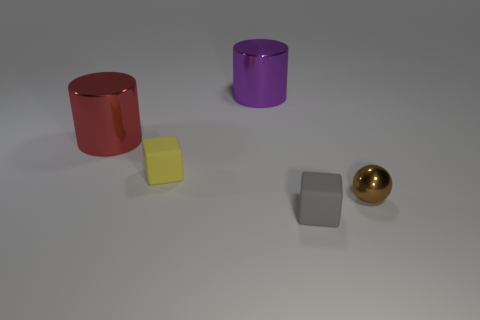What is the size of the brown object that is the same material as the red cylinder?
Keep it short and to the point. Small. Is the number of small yellow objects greater than the number of brown shiny blocks?
Give a very brief answer. Yes. What is the color of the metallic thing that is in front of the large red object?
Make the answer very short. Brown. There is a object that is on the left side of the ball and on the right side of the big purple cylinder; what size is it?
Make the answer very short. Small. How many yellow rubber things have the same size as the gray matte block?
Offer a terse response. 1. What material is the red thing that is the same shape as the purple metal object?
Your answer should be very brief. Metal. Does the red thing have the same shape as the yellow thing?
Ensure brevity in your answer.  No. How many red metal things are right of the small ball?
Provide a succinct answer. 0. There is a shiny object to the left of the big thing right of the tiny yellow rubber thing; what shape is it?
Your response must be concise. Cylinder. What is the shape of the large purple object that is the same material as the small ball?
Make the answer very short. Cylinder. 